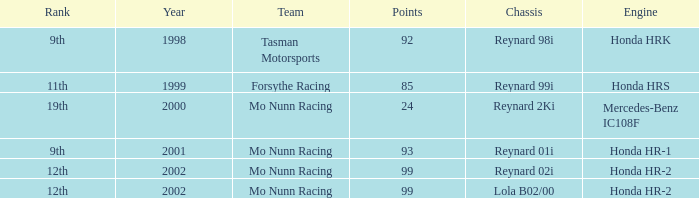What is the total number of points of the honda hr-1 engine? 1.0. 